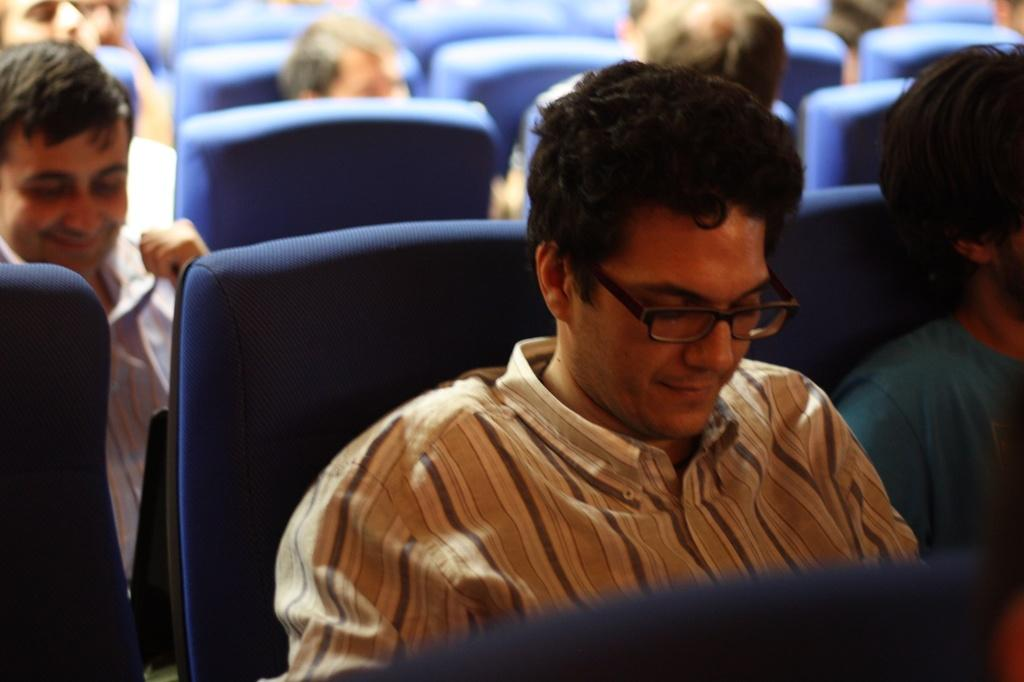How many people are in the image? There are persons in the image, but the exact number is not specified. What are the persons doing in the image? The persons are sitting on seats in the image. What type of apples are being judged by the judge in the image? There is no judge or apples present in the image; it only shows persons sitting on seats. 